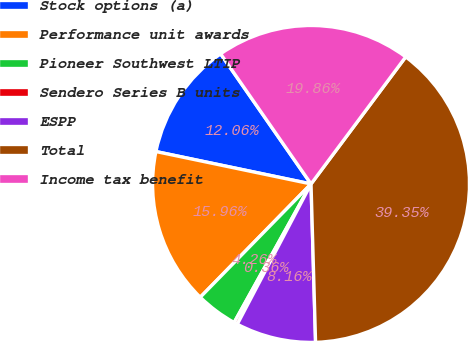Convert chart. <chart><loc_0><loc_0><loc_500><loc_500><pie_chart><fcel>Stock options (a)<fcel>Performance unit awards<fcel>Pioneer Southwest LTIP<fcel>Sendero Series B units<fcel>ESPP<fcel>Total<fcel>Income tax benefit<nl><fcel>12.06%<fcel>15.96%<fcel>4.26%<fcel>0.36%<fcel>8.16%<fcel>39.36%<fcel>19.86%<nl></chart> 